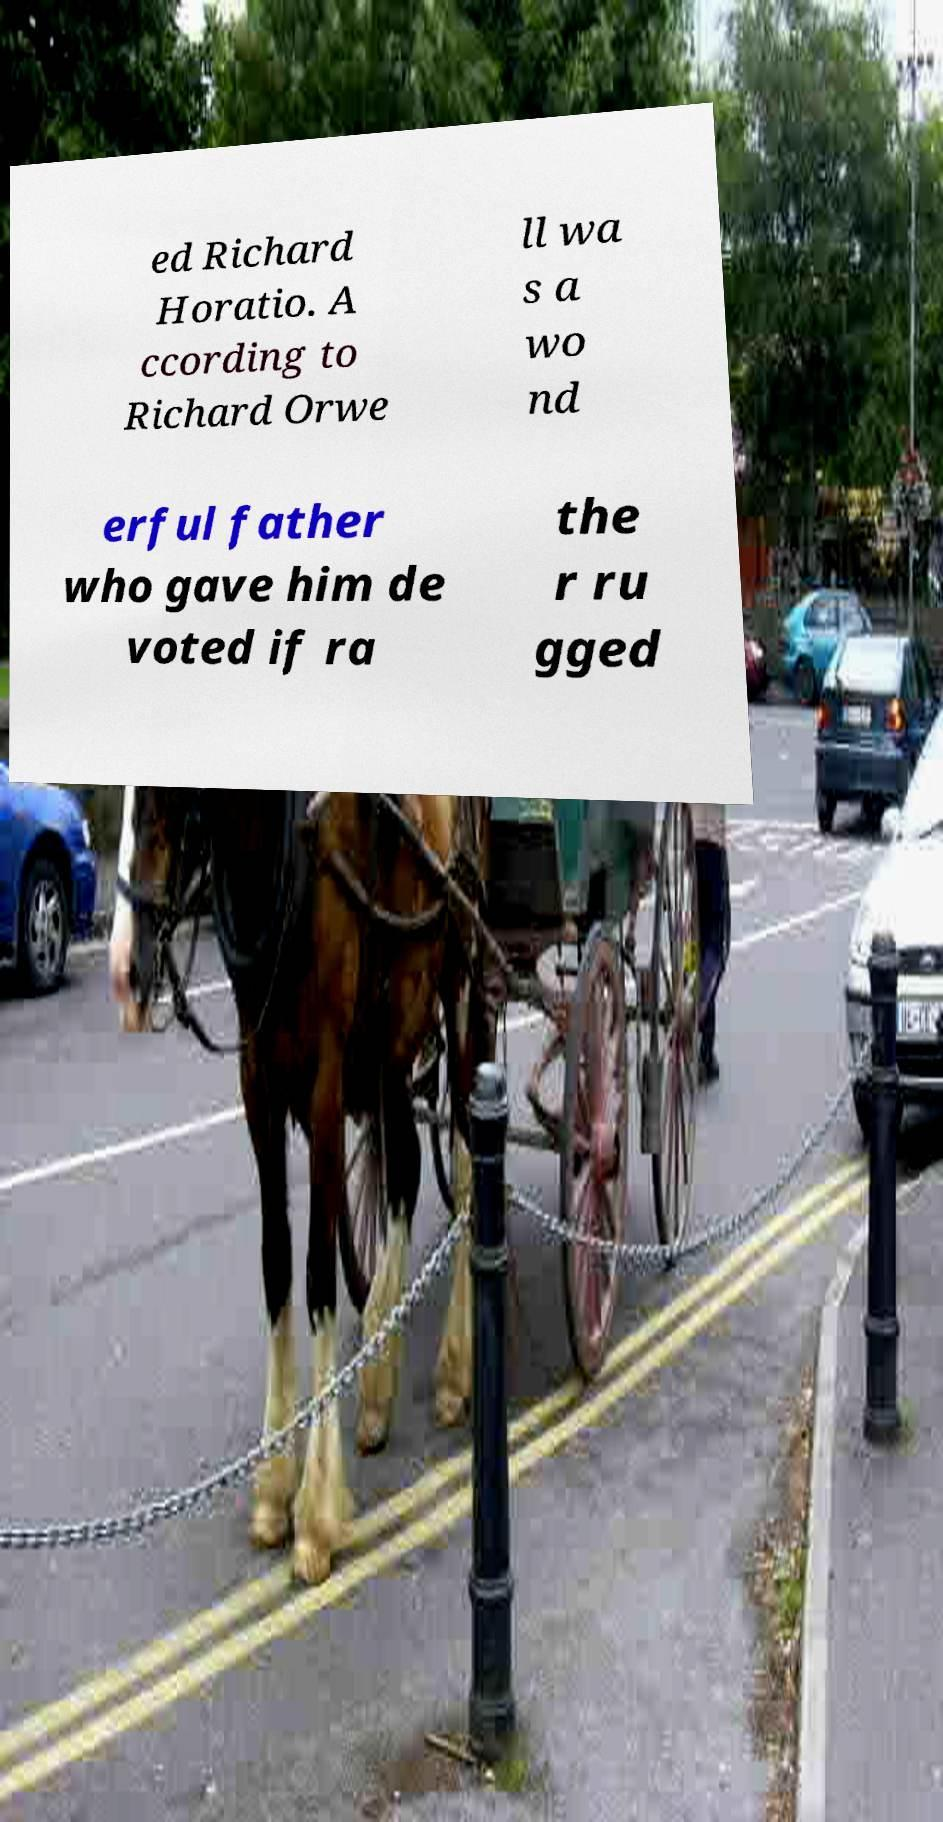For documentation purposes, I need the text within this image transcribed. Could you provide that? ed Richard Horatio. A ccording to Richard Orwe ll wa s a wo nd erful father who gave him de voted if ra the r ru gged 